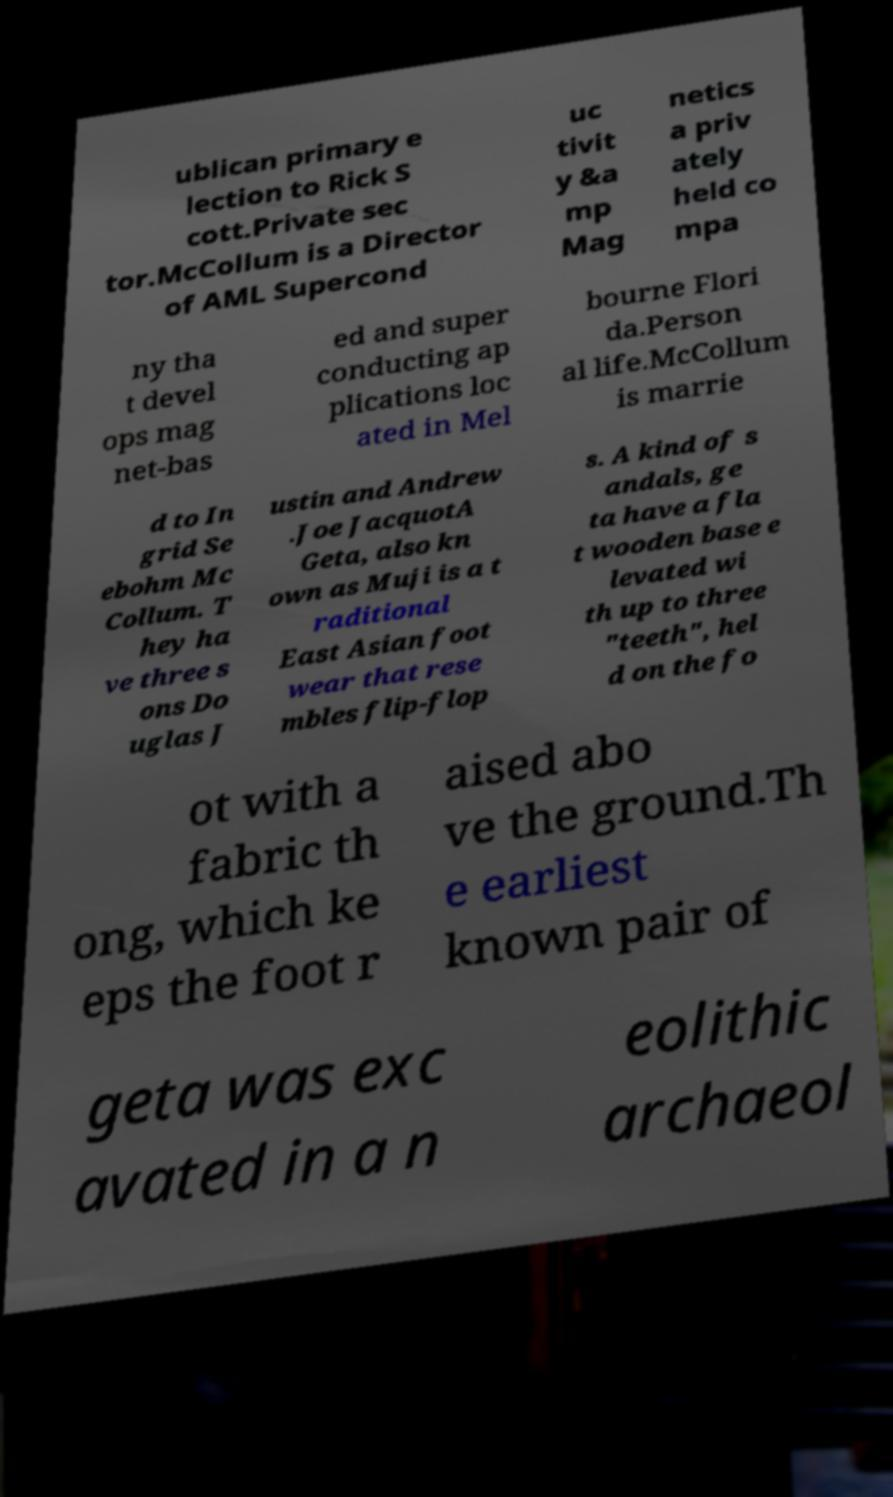I need the written content from this picture converted into text. Can you do that? ublican primary e lection to Rick S cott.Private sec tor.McCollum is a Director of AML Supercond uc tivit y &a mp Mag netics a priv ately held co mpa ny tha t devel ops mag net-bas ed and super conducting ap plications loc ated in Mel bourne Flori da.Person al life.McCollum is marrie d to In grid Se ebohm Mc Collum. T hey ha ve three s ons Do uglas J ustin and Andrew .Joe JacquotA Geta, also kn own as Muji is a t raditional East Asian foot wear that rese mbles flip-flop s. A kind of s andals, ge ta have a fla t wooden base e levated wi th up to three "teeth", hel d on the fo ot with a fabric th ong, which ke eps the foot r aised abo ve the ground.Th e earliest known pair of geta was exc avated in a n eolithic archaeol 